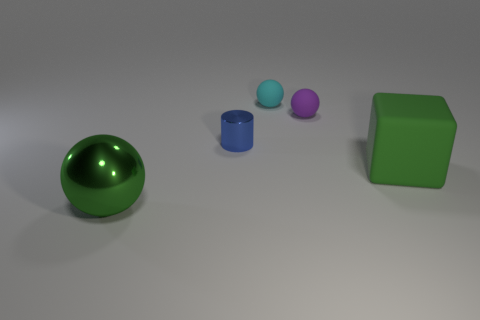Is the big ball the same color as the large matte block?
Keep it short and to the point. Yes. There is a green sphere; what number of cyan matte objects are in front of it?
Your answer should be compact. 0. There is a large shiny thing; is its shape the same as the small cyan object on the right side of the green metallic object?
Your answer should be very brief. Yes. Are there any other things that have the same shape as the green metal thing?
Your response must be concise. Yes. What shape is the large object left of the big green object that is behind the big green metal sphere?
Keep it short and to the point. Sphere. The metal object in front of the cube has what shape?
Your answer should be very brief. Sphere. Does the object that is in front of the block have the same color as the big thing that is right of the purple ball?
Ensure brevity in your answer.  Yes. What number of green things are on the right side of the small shiny thing and left of the tiny purple matte ball?
Keep it short and to the point. 0. There is a cyan ball that is made of the same material as the purple object; what size is it?
Provide a short and direct response. Small. The purple matte sphere is what size?
Your answer should be very brief. Small. 